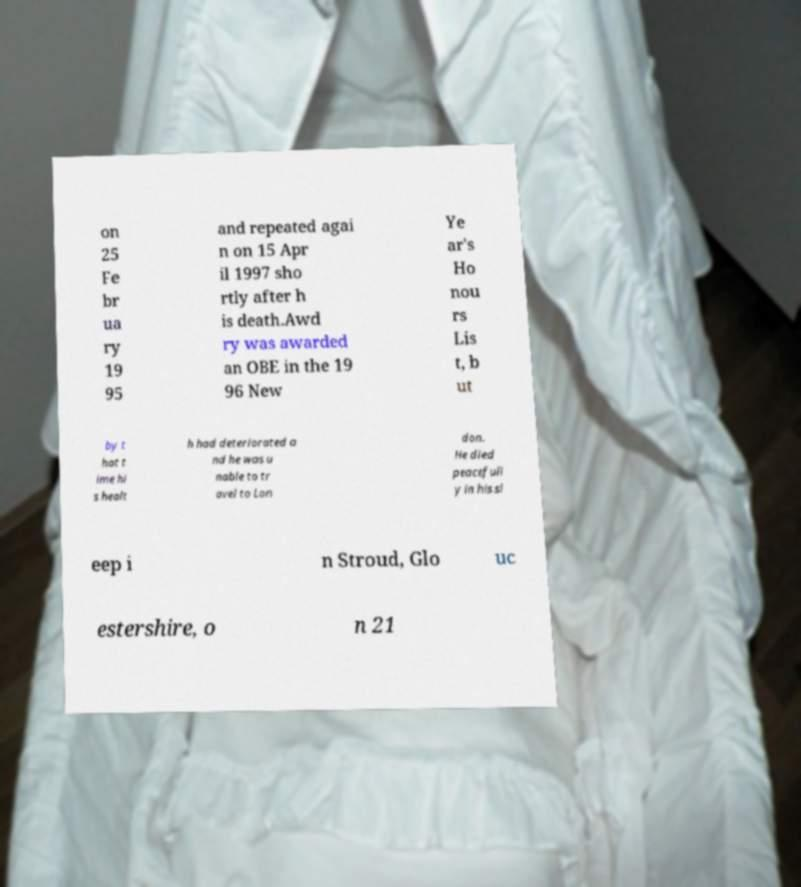I need the written content from this picture converted into text. Can you do that? on 25 Fe br ua ry 19 95 and repeated agai n on 15 Apr il 1997 sho rtly after h is death.Awd ry was awarded an OBE in the 19 96 New Ye ar's Ho nou rs Lis t, b ut by t hat t ime hi s healt h had deteriorated a nd he was u nable to tr avel to Lon don. He died peacefull y in his sl eep i n Stroud, Glo uc estershire, o n 21 